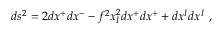Convert formula to latex. <formula><loc_0><loc_0><loc_500><loc_500>d s ^ { 2 } = 2 d x ^ { + } d x ^ { - } - f ^ { 2 } x _ { I } ^ { 2 } d x ^ { + } d x ^ { + } + d x ^ { I } d x ^ { I } ,</formula> 